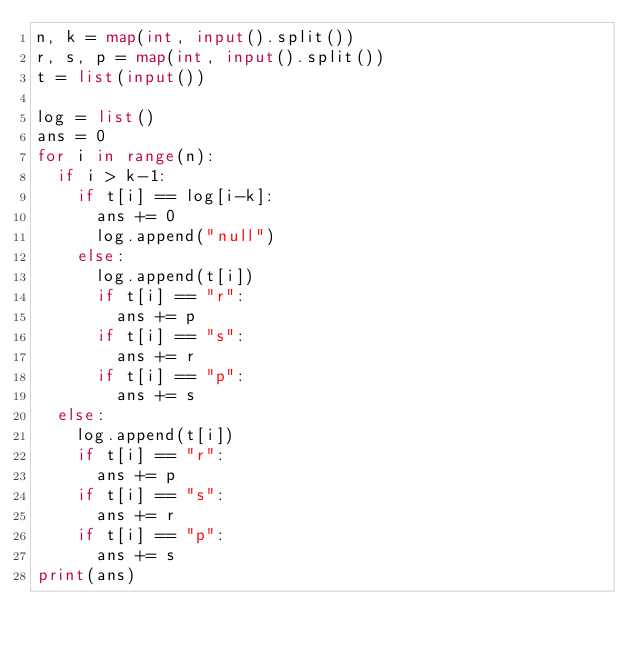<code> <loc_0><loc_0><loc_500><loc_500><_Python_>n, k = map(int, input().split())
r, s, p = map(int, input().split())
t = list(input())

log = list()
ans = 0
for i in range(n):
  if i > k-1:
    if t[i] == log[i-k]:
      ans += 0
      log.append("null")
    else:
      log.append(t[i])
      if t[i] == "r":
        ans += p
      if t[i] == "s":
        ans += r
      if t[i] == "p":
        ans += s  
  else:
    log.append(t[i])
    if t[i] == "r":
      ans += p
    if t[i] == "s":
      ans += r
    if t[i] == "p":
      ans += s  
print(ans)</code> 